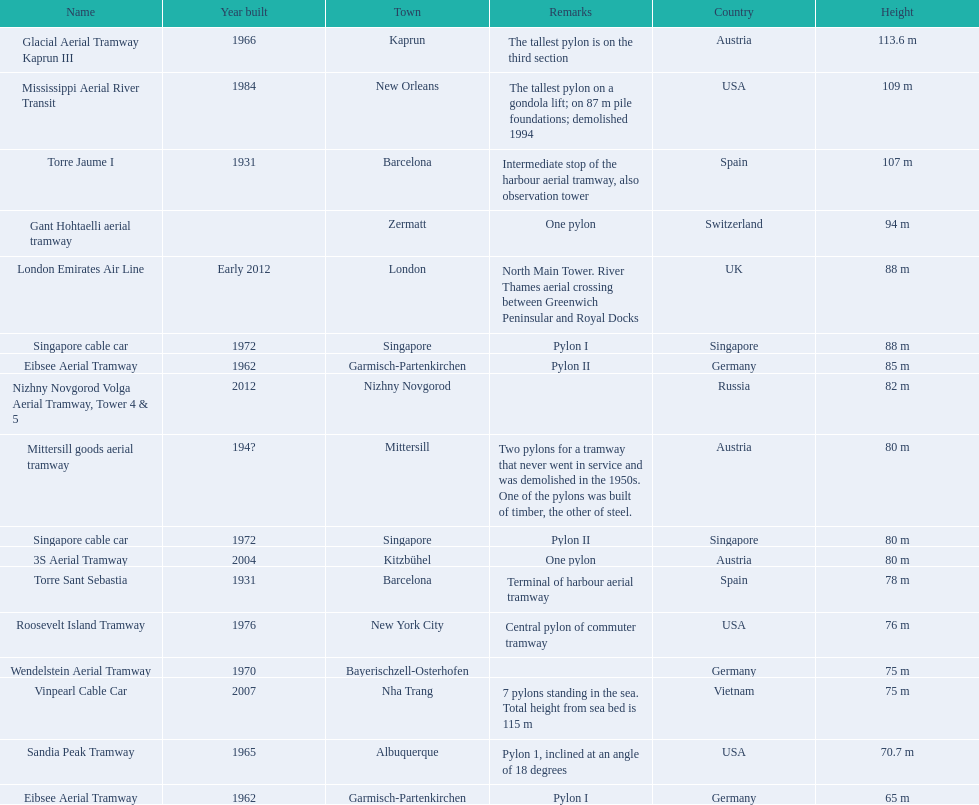Which aerial lifts are over 100 meters tall? Glacial Aerial Tramway Kaprun III, Mississippi Aerial River Transit, Torre Jaume I. Which of those was built last? Mississippi Aerial River Transit. And what is its total height? 109 m. 